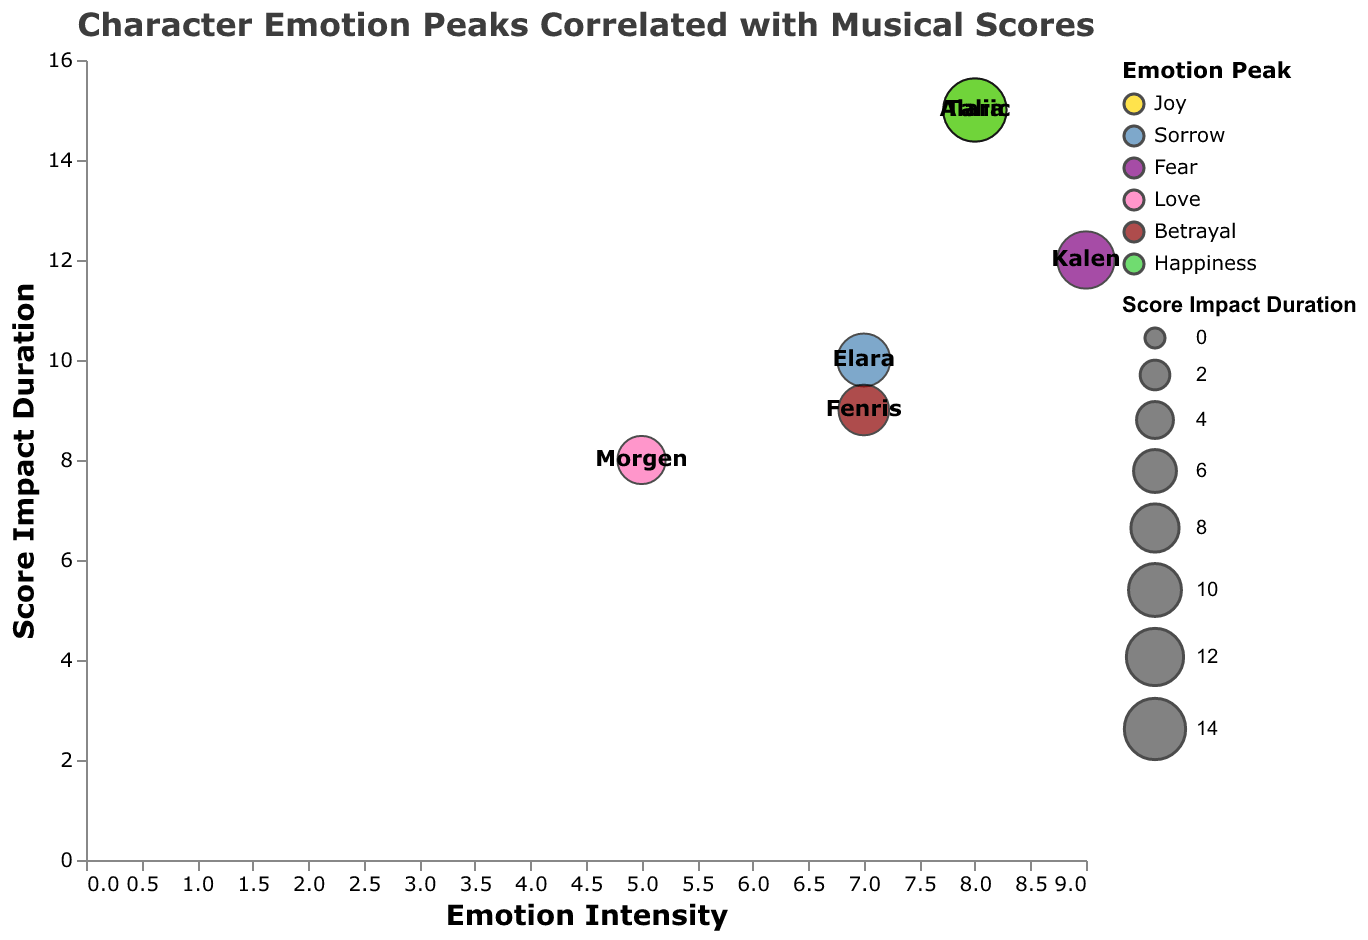What's the title of the chart? The title is displayed prominently at the top of the chart.
Answer: Character Emotion Peaks Correlated with Musical Scores How many characters have an Emotion Intensity of 8? Two data points on the x-axis are at the value of 8.
Answer: Two Who has the highest Emotion Intensity and what score is associated with it? Look for the highest value on the x-axis; Kalen has an Emotion Intensity of 9 and is associated with "Requiem - Mozart".
Answer: Kalen, Requiem - Mozart What is the color representing the "Fear" emotion? Each emotion peak is represented by a specific color; "Fear" is represented by purple.
Answer: Purple Which character has the lowest Score Impact Duration, and what is the duration? Find the smallest value on the y-axis, which belongs to Morgen with a duration of 8.
Answer: Morgen, 8 Which character experiences the emotion of "Betrayal" and what is their Emotion Intensity? Look for the data point with the label "Betrayal"; Fenris has an Emotion Intensity of 7.
Answer: Fenris, 7 Compare the Score Impact Duration between Alaric and Talia. Who has the longer duration? Both Alaric and Talia have a Score Impact Duration of 15, so neither is longer.
Answer: They are equal, 15 What is the average Emotion Intensity of all characters? Sum the intensities (8 + 7 + 9 + 5 + 7 + 8) = 44 and divide by the number of characters, which is 6. The average is 44/6.
Answer: About 7.33 Between the emotions of "Joy" and "Sorrow", which has a higher associated Emotion Intensity? "Joy" (Alaric) has an Intensity of 8, while "Sorrow" (Elara) has an Intensity of 7. Therefore, "Joy" has a higher Intensity.
Answer: Joy How does "Score Impact Duration" generally correlate with "Emotion Intensity" in the chart? Examine the scatter of data points; there is no clear linear relationship visible. Thus, the correlation might be weak or non-existent.
Answer: Weak or non-existent 